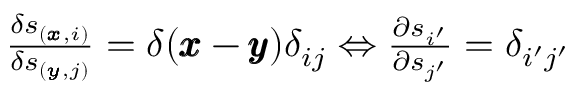Convert formula to latex. <formula><loc_0><loc_0><loc_500><loc_500>\begin{array} { r } { \frac { \delta \ m a t h s c r { s } _ { ( \pm b { x } , i ) } } { \delta \ m a t h s c r { s } _ { ( \pm b { y } , j ) } } = \delta ( \pm b { x } - \pm b { y } ) \delta _ { i j } \Leftrightarrow \frac { \partial \ m a t h s c r { s } _ { i ^ { \prime } } } { \partial \ m a t h s c r { s } _ { j ^ { \prime } } } = \delta _ { i ^ { \prime } j ^ { \prime } } } \end{array}</formula> 